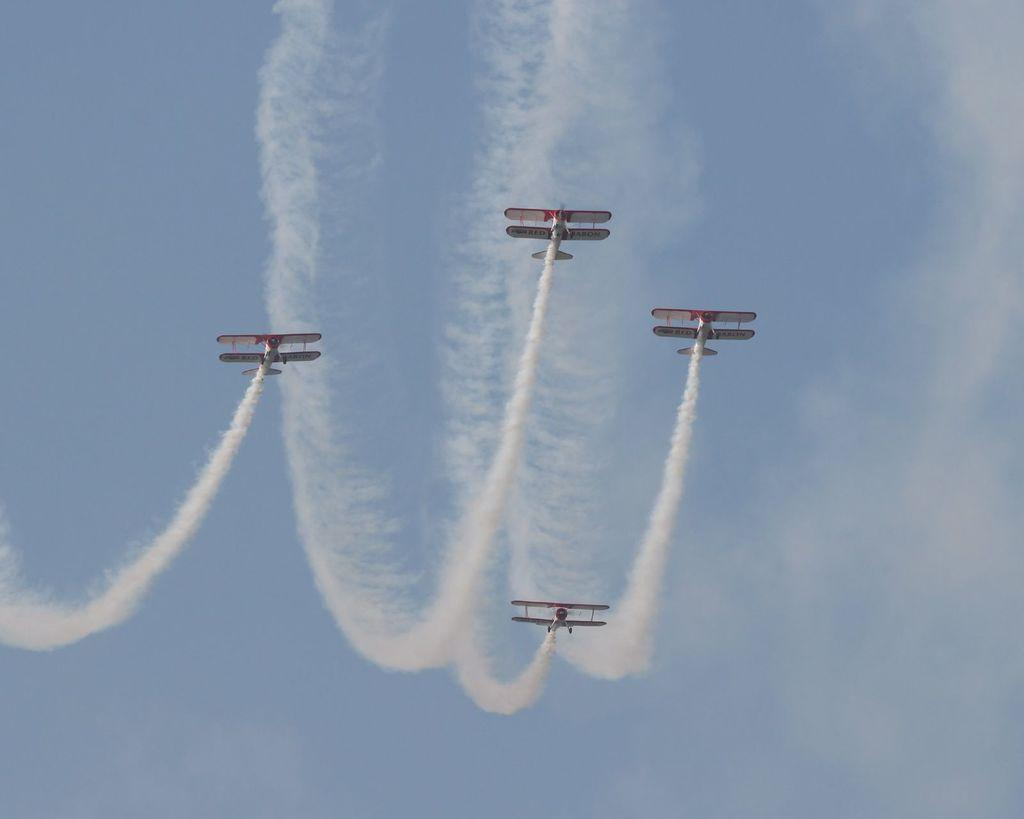How many aircraft are present in the image? There are four aircraft in the image. What are the aircraft doing in the image? The aircraft are flying in the sky. What can be seen in the sky along with the aircraft? There is white smoke visible in the image. What type of ice can be seen melting on the wing of the aircraft in the image? There is no ice visible on the aircraft in the image. What kind of machine is being used to create the white smoke in the image? The image does not provide information about the source of the white smoke, so it cannot be determined which machine, if any, is responsible for it. 